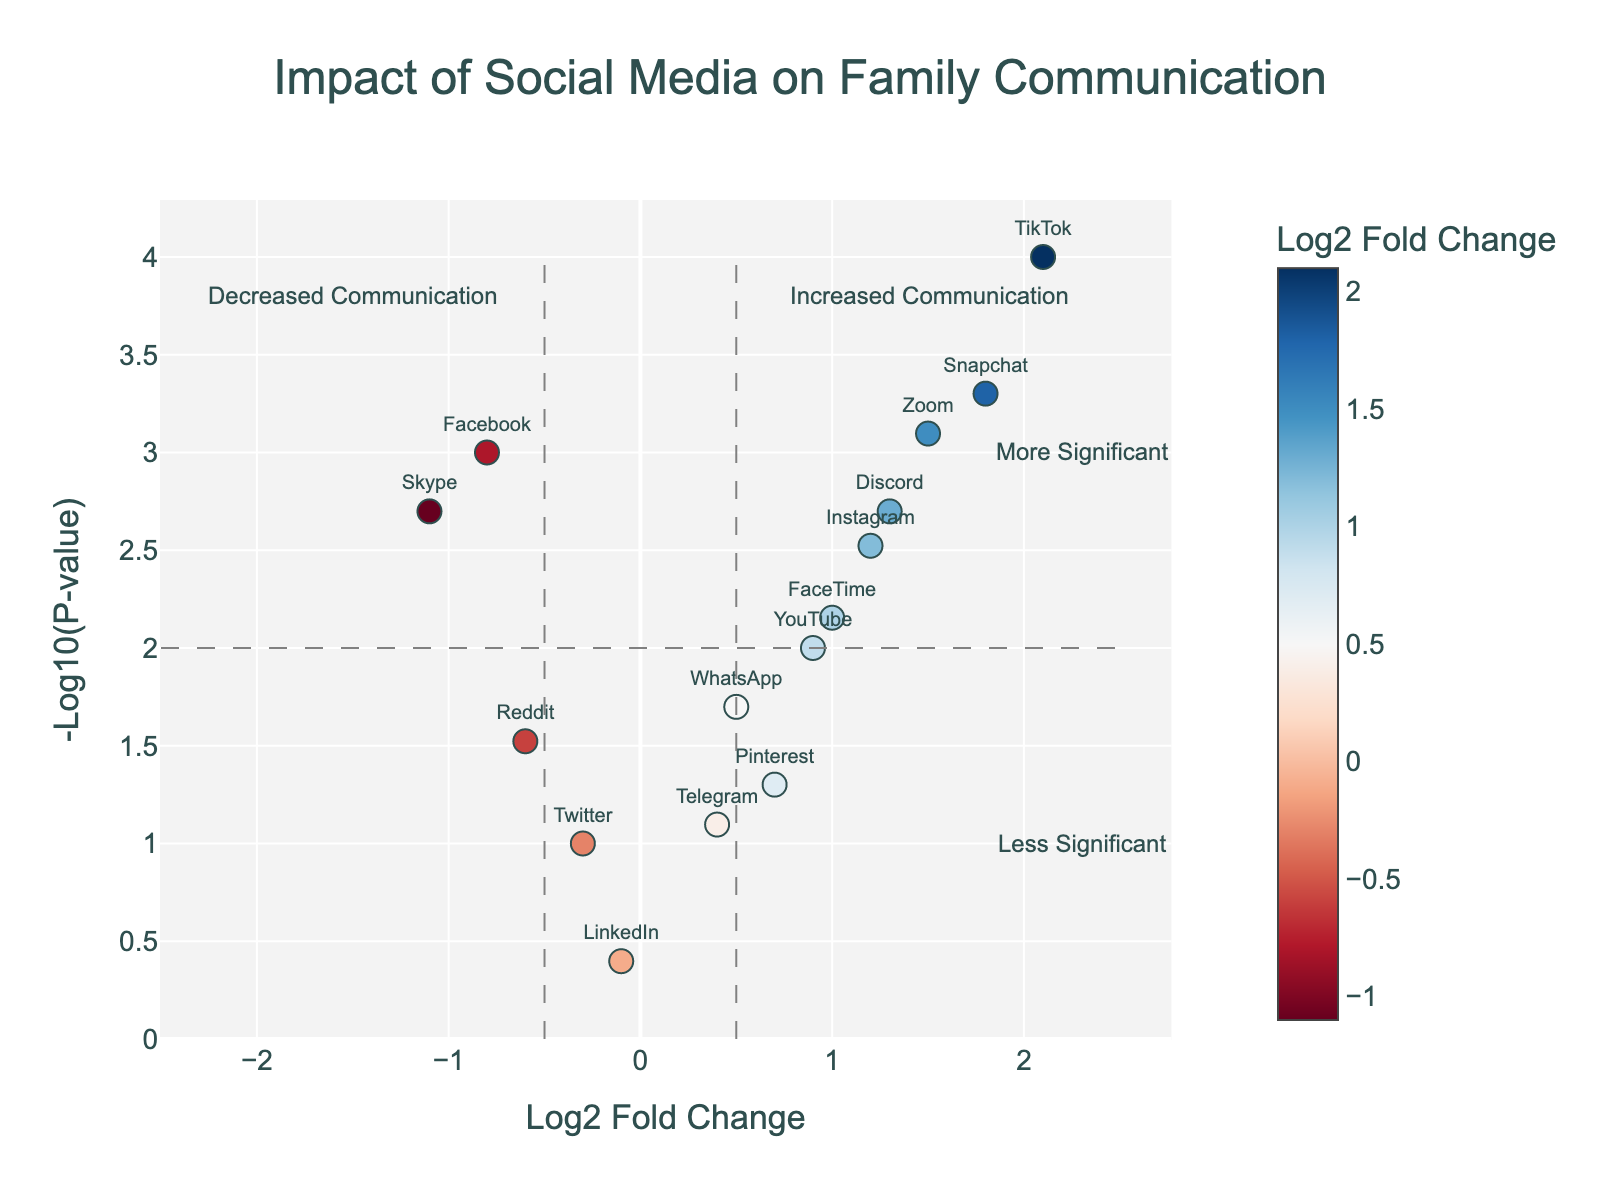How many data points are plotted in the figure? The plot contains one data point for each social media platform listed in the dataset. Counting the platforms, we get a total of 15 data points.
Answer: 15 Which social media platform shows the highest increase in family communication? The platform with the highest log2 fold change indicates the greatest increase. TikTok has the highest log2 fold change at 2.1.
Answer: TikTok Which social media platform has the lowest p-value? The p-value indicates statistical significance. TikTok has the lowest p-value at 0.0001, indicated by the highest -log10(p-value).
Answer: TikTok Which platforms show a significant decrease in family communication? To be significant, platforms need a p-value below 0.05 (-log10(p) above approximately 1.3) and a negative log2 fold change. Facebook and Skype fit these criteria.
Answer: Facebook, Skype What is the log2 fold change of YouTube, and is it statistically significant? YouTube has a log2 fold change of 0.9 and a p-value of 0.01, which means it is statistically significant as the p-value is below 0.05.
Answer: 0.9, Yes Compare the significance levels (-log10(p-values)) of Facebook and Snapchat. Which is more significant? Comparing -log10(p-values): Facebook (-log10(0.001) = 3) and Snapchat (-log10(0.0005) = 3.3). Snapchat is more significant.
Answer: Snapchat Is there any platform that has a log2 fold change of less than -1? If so, which one? A log2 fold change less than -1 indicates a strong decrease. Skype has a log2 fold change of -1.1.
Answer: Skype Which social media platforms increase communication but are not very significant? Platforms with positive log2 fold change and p-value greater than 0.05 (-log10(p) less than 1.3) include WhatsApp (0.5, 0.02), Pinterest (0.7, 0.05), and Telegram (0.4, 0.08). However, none of these have a p-value above 0.05.
Answer: None How does Discord's impact on communication compare to Instagram's in terms of fold change and significance? Discord has a log2 fold change of 1.3 and p-value of 0.002, while Instagram has a log2 fold change of 1.2 and p-value of 0.003. Discord has both a slightly higher fold change and a more significant p-value.
Answer: Discord has a higher impact and is more significant Between Zoom and TikTok, which platform shows a greater impact on communication change, and how do their significance levels compare? Zoom has a log2 fold change of 1.5 and p-value of 0.0008, while TikTok has a log2 fold change of 2.1 and p-value of 0.0001. TikTok shows a greater impact and higher significance.
Answer: TikTok has a greater impact and higher significance 